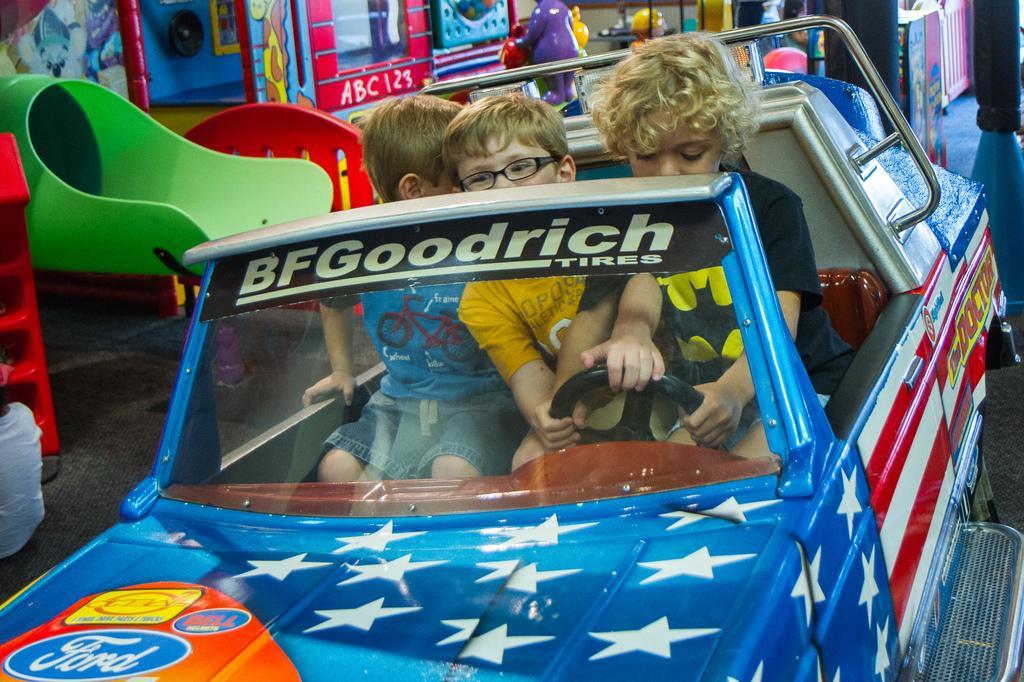Describe this image in one or two sentences. Here we can see three children sitting in a toy car and these children are present in a Play station we can say it by seeing the surroundings 